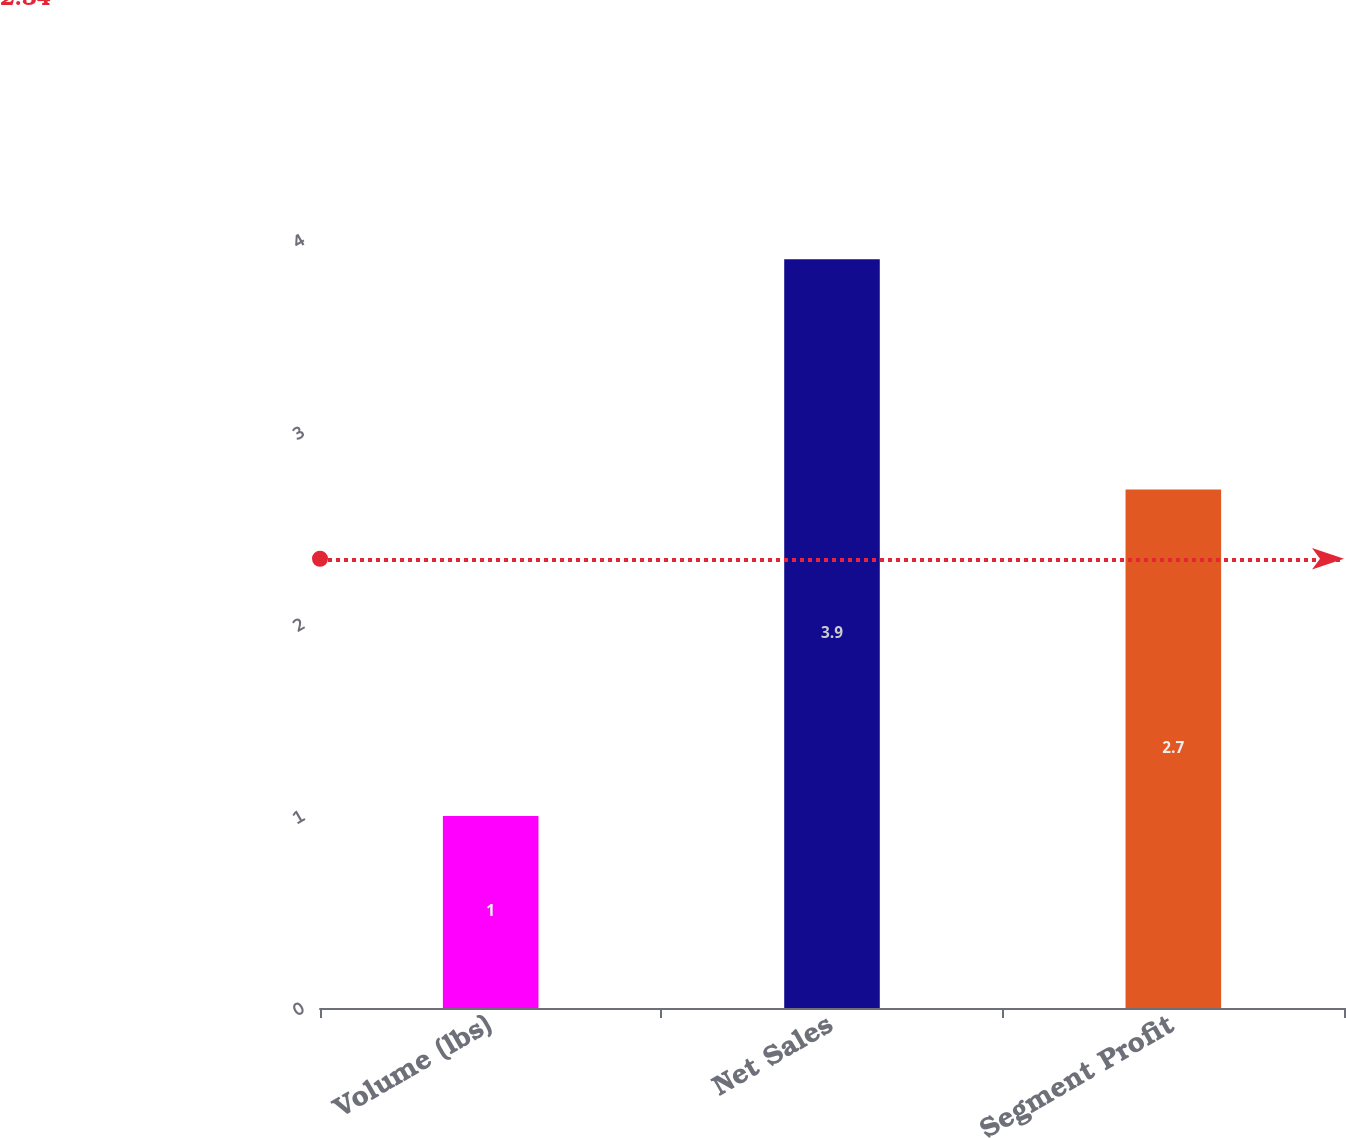Convert chart. <chart><loc_0><loc_0><loc_500><loc_500><bar_chart><fcel>Volume (lbs)<fcel>Net Sales<fcel>Segment Profit<nl><fcel>1<fcel>3.9<fcel>2.7<nl></chart> 